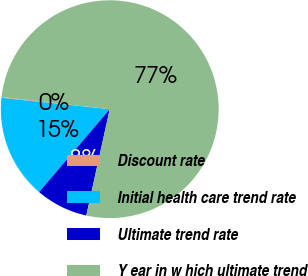<chart> <loc_0><loc_0><loc_500><loc_500><pie_chart><fcel>Discount rate<fcel>Initial health care trend rate<fcel>Ultimate trend rate<fcel>Y ear in w hich ultimate trend<nl><fcel>0.12%<fcel>15.43%<fcel>7.78%<fcel>76.67%<nl></chart> 